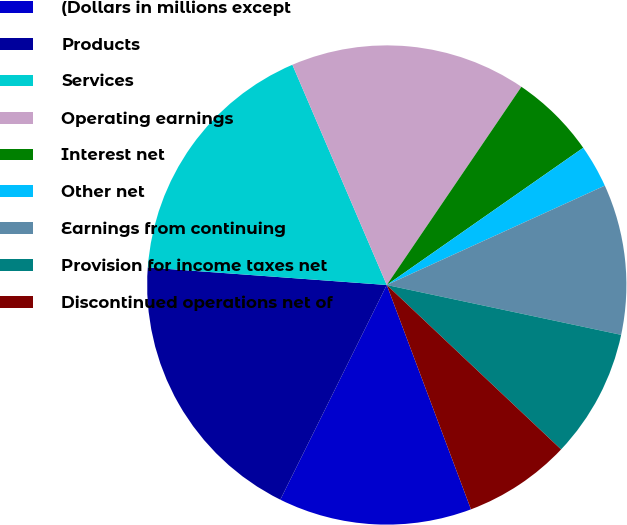<chart> <loc_0><loc_0><loc_500><loc_500><pie_chart><fcel>(Dollars in millions except<fcel>Products<fcel>Services<fcel>Operating earnings<fcel>Interest net<fcel>Other net<fcel>Earnings from continuing<fcel>Provision for income taxes net<fcel>Discontinued operations net of<nl><fcel>13.04%<fcel>18.84%<fcel>17.39%<fcel>15.94%<fcel>5.8%<fcel>2.9%<fcel>10.14%<fcel>8.7%<fcel>7.25%<nl></chart> 